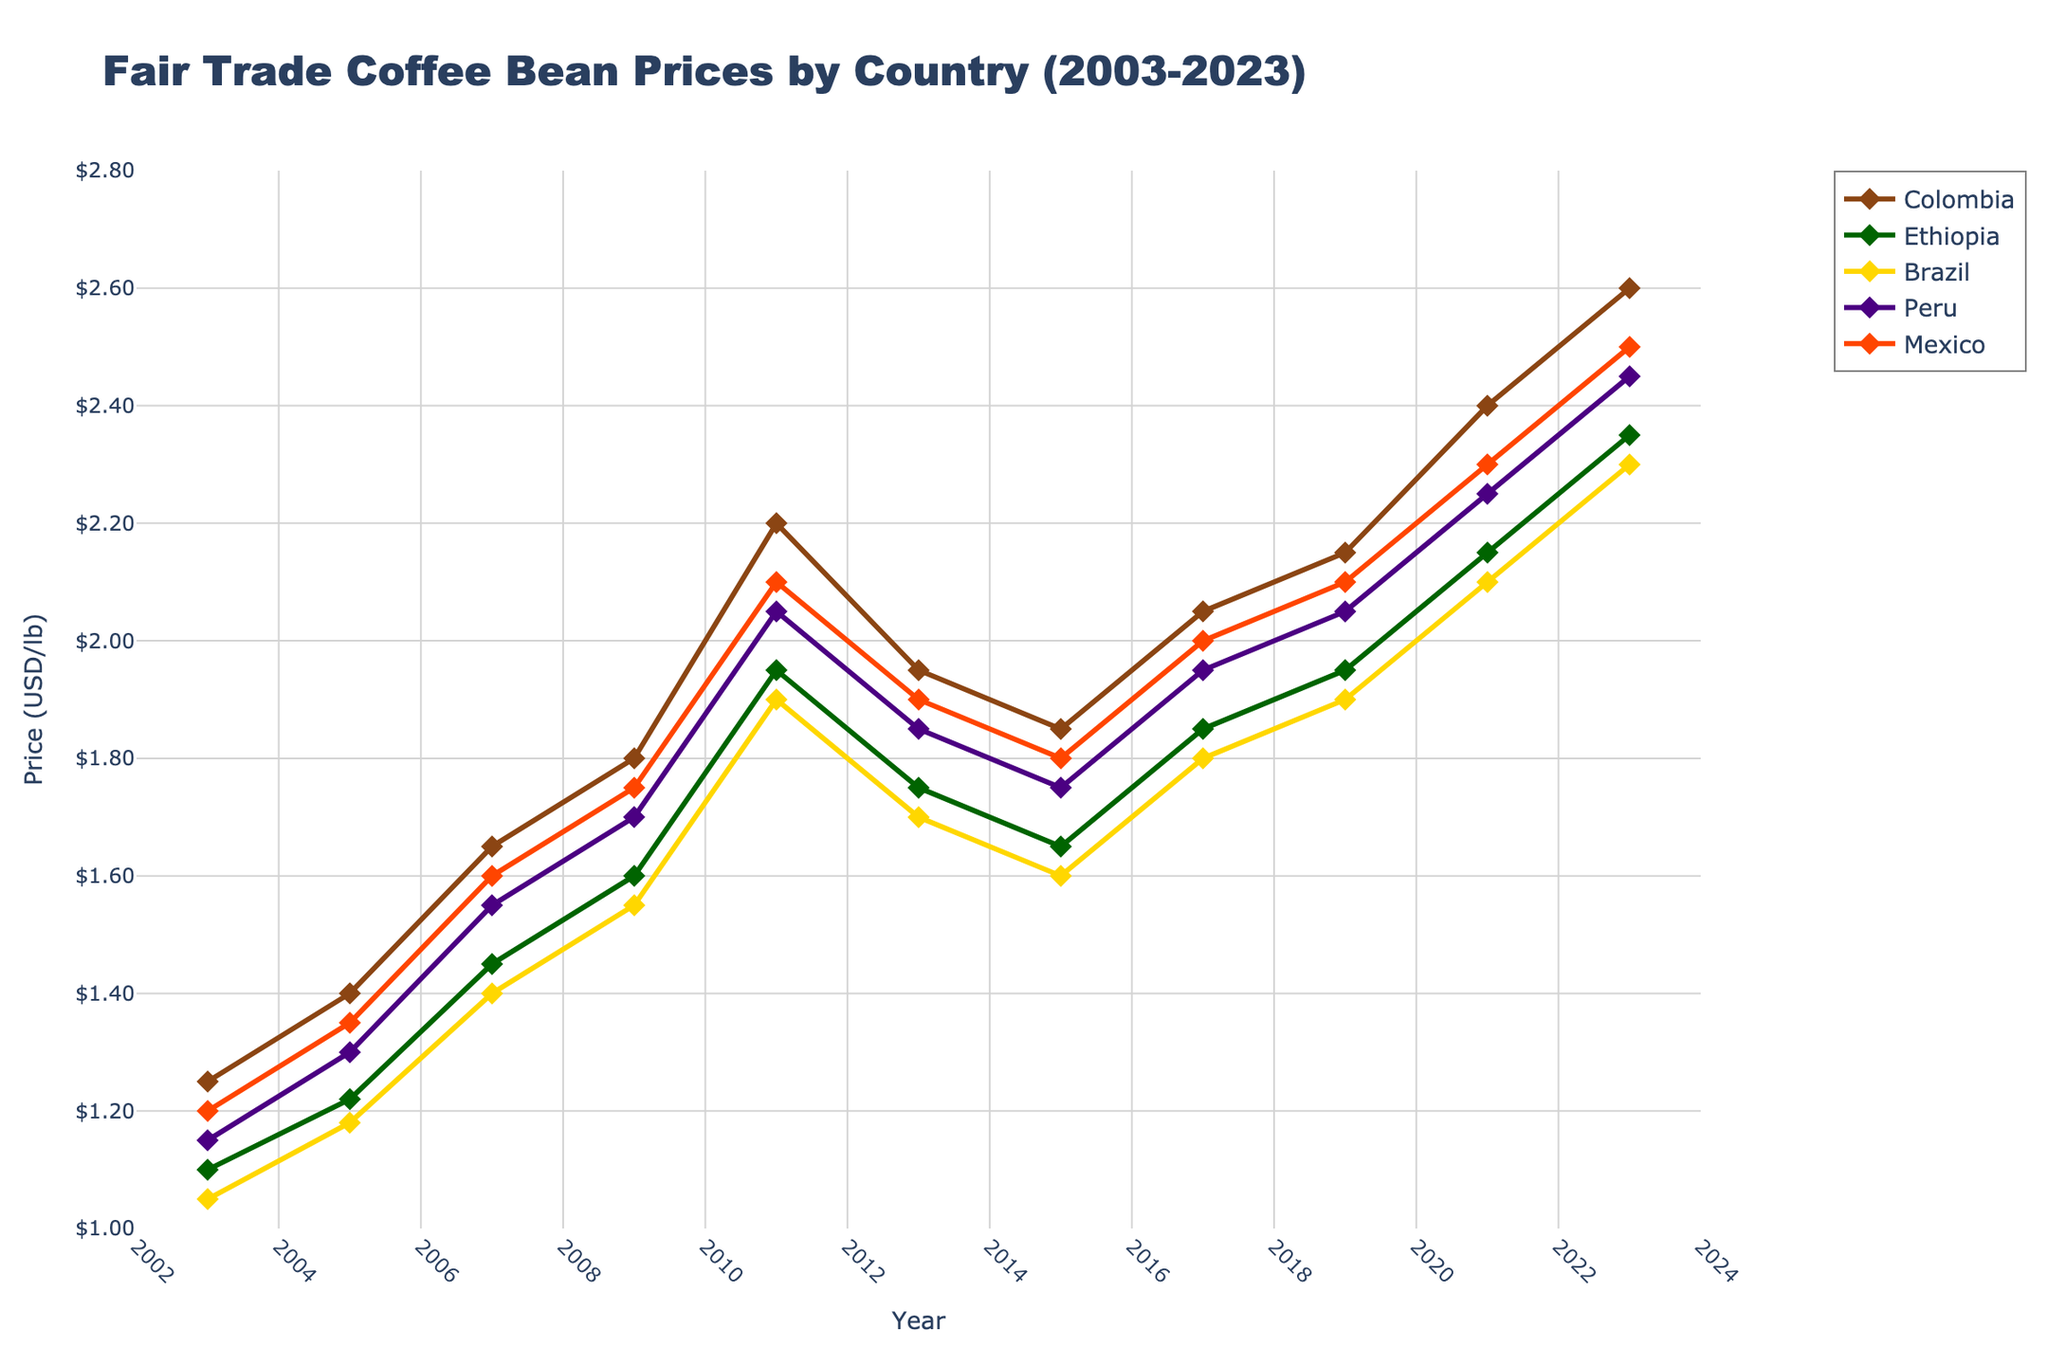What's the highest fair trade coffee bean price recorded over the 20 years? To find the highest price, look at the highest points on the y-axis for all countries from 2003 to 2023. The maximum price is 2.60 USD per pound recorded by Colombia in 2023.
Answer: 2.60 USD/lb In which year did Ethiopia's coffee bean price match Mexico's price? Look at the data points of Ethiopia and Mexico lines and check when they overlap. Both Ethiopia and Mexico had the same price of 1.95 USD per pound in 2019.
Answer: 2019 Which country showed the most consistent increase in coffee bean prices over the period? Assess the trend lines for all countries and identify the line that consistently trends upward without major dips. Colombia shows the most consistent increase from 2003 to 2023.
Answer: Colombia What’s the average price of Brazil's coffee beans in the years shown? To calculate the average, sum up Brazil's prices from 2003 to 2023 and divide by the number of years. (1.05 + 1.18 + 1.40 + 1.55 + 1.90 + 1.70 + 1.60 + 1.80 + 1.90 + 2.10 + 2.30) / 11 = 1.684 USD/lb
Answer: 1.68 USD/lb Comparing Peru and Mexico, which year had the smallest price difference, and what was the difference? Examine the lines for Peru and Mexico and find the year with the least vertical separation between them. In 2023, Peru and Mexico's prices were 2.45 USD and 2.50 USD respectively, the difference is 0.05 USD.
Answer: 2023, 0.05 USD Which year observed the maximum number of countries exceeding 2 USD/lb in coffee bean prices? Identify the points above the 2 USD line for every country and count the number of countries in each year. In 2023, all five countries recorded prices above 2 USD/lb.
Answer: 2023 How did the price of Colombia's coffee beans change between 2007 and 2009? Check the price of Colombia in 2007 and 2009 and calculate the difference. The price increased from 1.65 USD/lb in 2007 to 1.80 USD/lb in 2009, an increase of 0.15 USD/lb.
Answer: Increased by 0.15 USD/lb Which country had the sharpest increase in coffee prices between 2009 and 2011? Compare the slopes for each country from 2009 to 2011. The steepest line corresponds to Colombia, which increased from 1.80 USD/lb to 2.20 USD/lb, an increase of 0.40 USD/lb.
Answer: Colombia Which country's coffee prices exceeded the overall average price more frequently? Calculate the average price for each year and count the years each country's price was above this average. Colombia’s prices exceeded the yearly average more frequently than any other country.
Answer: Colombia 